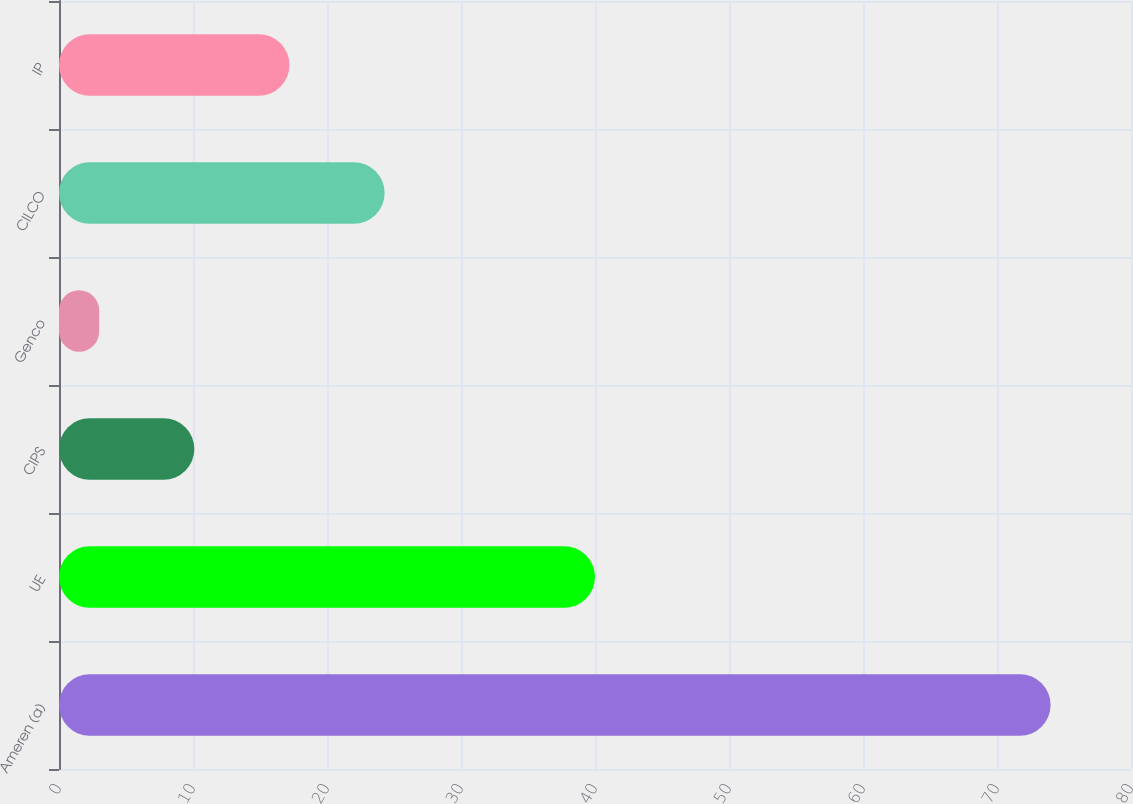<chart> <loc_0><loc_0><loc_500><loc_500><bar_chart><fcel>Ameren (a)<fcel>UE<fcel>CIPS<fcel>Genco<fcel>CILCO<fcel>IP<nl><fcel>74<fcel>40<fcel>10.1<fcel>3<fcel>24.3<fcel>17.2<nl></chart> 